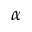Convert formula to latex. <formula><loc_0><loc_0><loc_500><loc_500>\alpha</formula> 